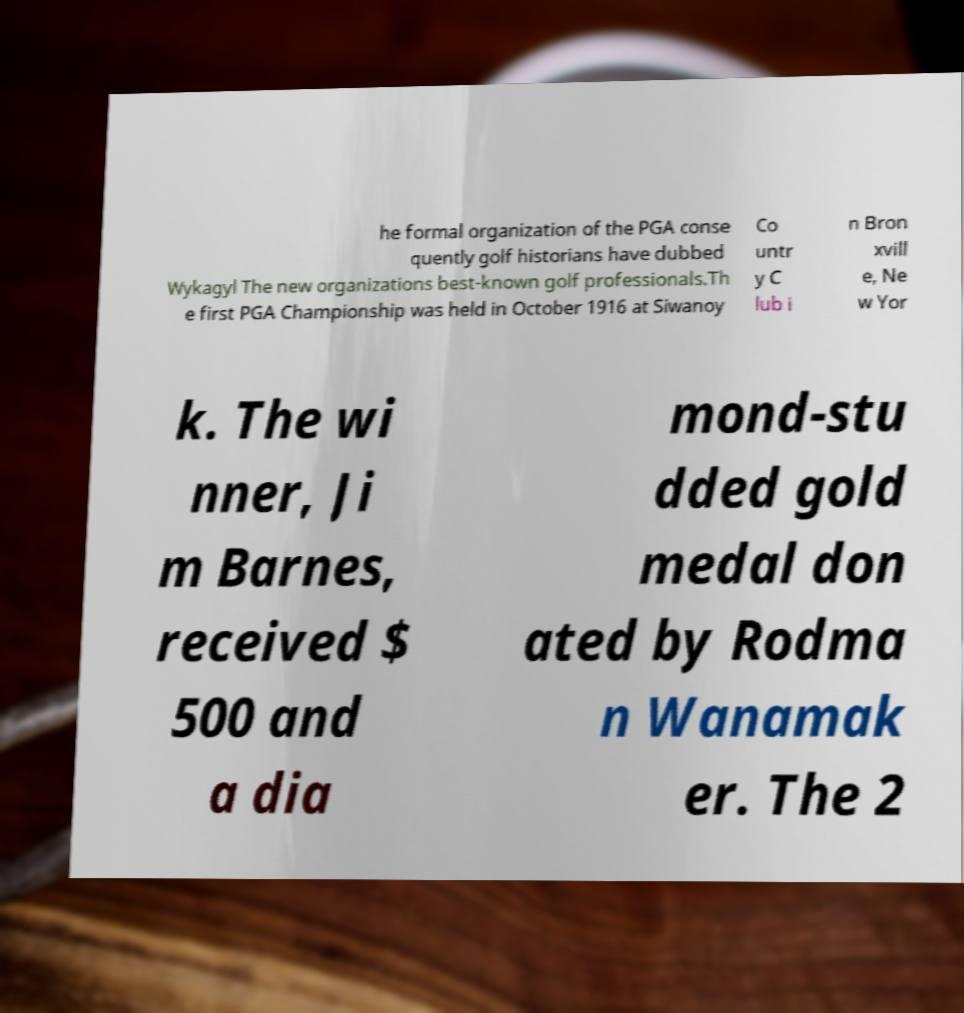Could you extract and type out the text from this image? he formal organization of the PGA conse quently golf historians have dubbed Wykagyl The new organizations best-known golf professionals.Th e first PGA Championship was held in October 1916 at Siwanoy Co untr y C lub i n Bron xvill e, Ne w Yor k. The wi nner, Ji m Barnes, received $ 500 and a dia mond-stu dded gold medal don ated by Rodma n Wanamak er. The 2 